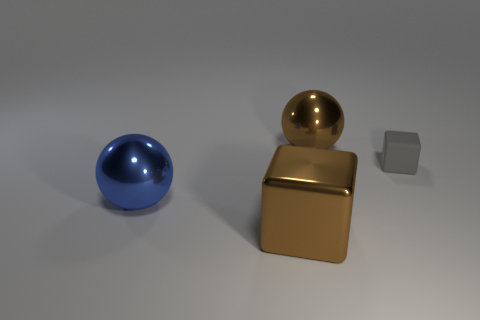What size is the metal object that is the same shape as the small gray matte thing?
Keep it short and to the point. Large. What number of things are shiny things to the right of the blue metal sphere or objects that are to the right of the big blue metallic object?
Offer a very short reply. 3. Are there fewer big brown spheres than small cyan matte spheres?
Provide a short and direct response. No. Is the size of the brown metal sphere the same as the shiny sphere that is to the left of the big brown block?
Your answer should be compact. Yes. What number of metal objects are either blue things or gray things?
Offer a terse response. 1. Are there more brown metallic balls than big yellow matte cylinders?
Ensure brevity in your answer.  Yes. The metallic thing that is the same color as the metallic cube is what size?
Your answer should be compact. Large. There is a brown object that is in front of the large shiny sphere that is behind the small gray thing; what is its shape?
Make the answer very short. Cube. There is a brown thing that is behind the metal sphere in front of the brown ball; are there any metal balls that are to the right of it?
Offer a very short reply. No. What is the color of the other metal ball that is the same size as the blue metal sphere?
Give a very brief answer. Brown. 